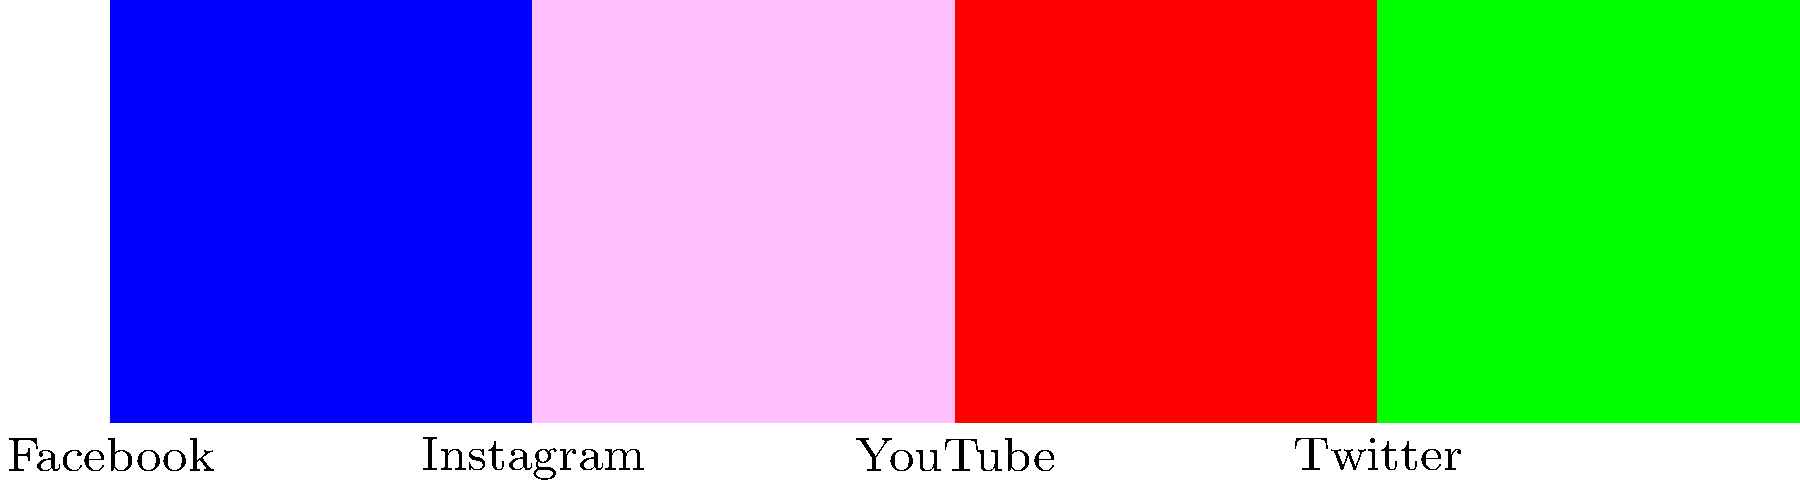Based on the bar graph showing the reach of different social media platforms for religious content, which platform has the second-highest percentage of reach, and what is the difference between its reach and that of the top platform? To answer this question, we need to follow these steps:

1. Identify the platform with the highest reach:
   Facebook has the tallest bar, representing 45% reach.

2. Identify the platform with the second-highest reach:
   Instagram has the second-tallest bar, representing 30% reach.

3. Calculate the difference between the top two platforms:
   $45\% - 30\% = 15\%$

Therefore, Instagram is the platform with the second-highest percentage of reach, and the difference between its reach and that of Facebook (the top platform) is 15%.
Answer: Instagram, 15% 